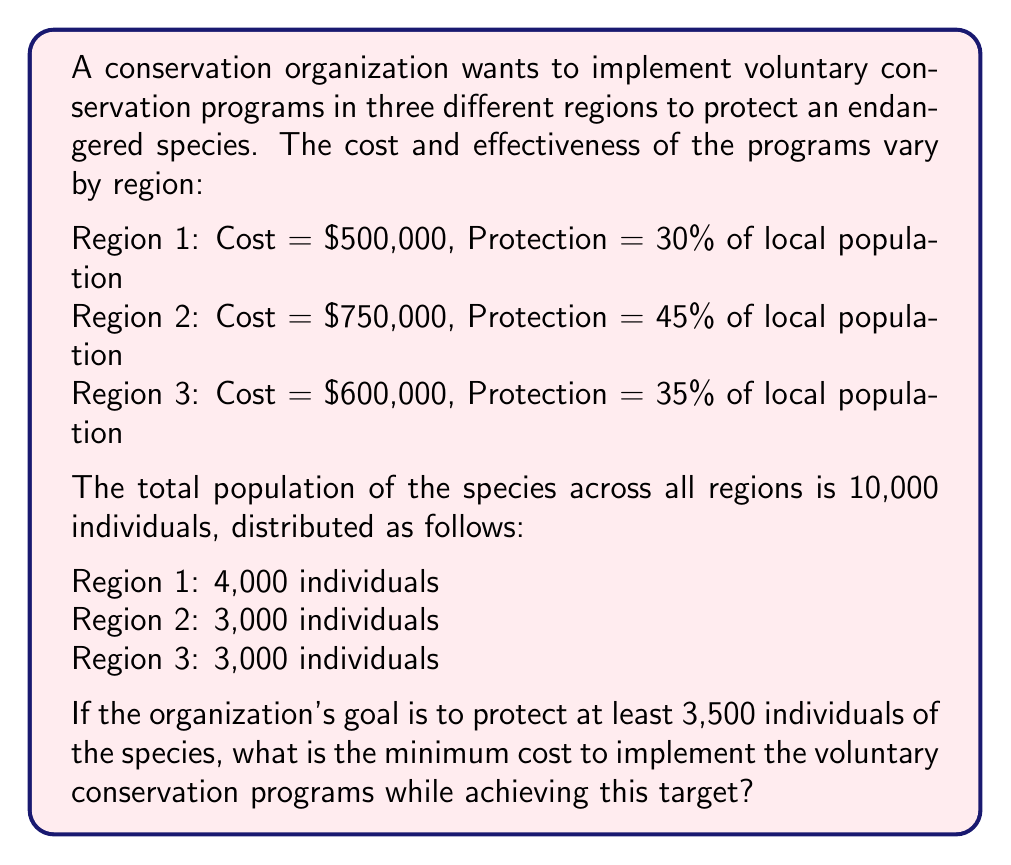What is the answer to this math problem? To solve this optimization problem, we'll use the following steps:

1. Calculate the number of individuals protected in each region:
   Region 1: $4000 \times 0.30 = 1200$ individuals
   Region 2: $3000 \times 0.45 = 1350$ individuals
   Region 3: $3000 \times 0.35 = 1050$ individuals

2. Set up a binary integer programming problem:
   Let $x_1$, $x_2$, and $x_3$ be binary variables representing whether we implement the program in each region (1) or not (0).

   Objective function (minimize cost):
   $$\text{Minimize } 500000x_1 + 750000x_2 + 600000x_3$$

   Constraint (protect at least 3500 individuals):
   $$1200x_1 + 1350x_2 + 1050x_3 \geq 3500$$

3. Solve the problem by considering all possible combinations:

   $$(x_1, x_2, x_3) \quad \text{Protected} \quad \text{Cost}$$
   $(0, 0, 0) \quad 0 \quad \$0$ (doesn't meet constraint)
   $(1, 0, 0) \quad 1200 \quad \$500,000$ (doesn't meet constraint)
   $(0, 1, 0) \quad 1350 \quad \$750,000$ (doesn't meet constraint)
   $(0, 0, 1) \quad 1050 \quad \$600,000$ (doesn't meet constraint)
   $(1, 1, 0) \quad 2550 \quad \$1,250,000$ (doesn't meet constraint)
   $(1, 0, 1) \quad 2250 \quad \$1,100,000$ (doesn't meet constraint)
   $(0, 1, 1) \quad 2400 \quad \$1,350,000$ (doesn't meet constraint)
   $(1, 1, 1) \quad 3600 \quad \$1,850,000$ (meets constraint)

4. The minimum cost solution that meets the constraint is to implement the program in all three regions, protecting 3600 individuals at a cost of $1,850,000.
Answer: The minimum cost to implement the voluntary conservation programs while protecting at least 3,500 individuals of the species is $1,850,000. 